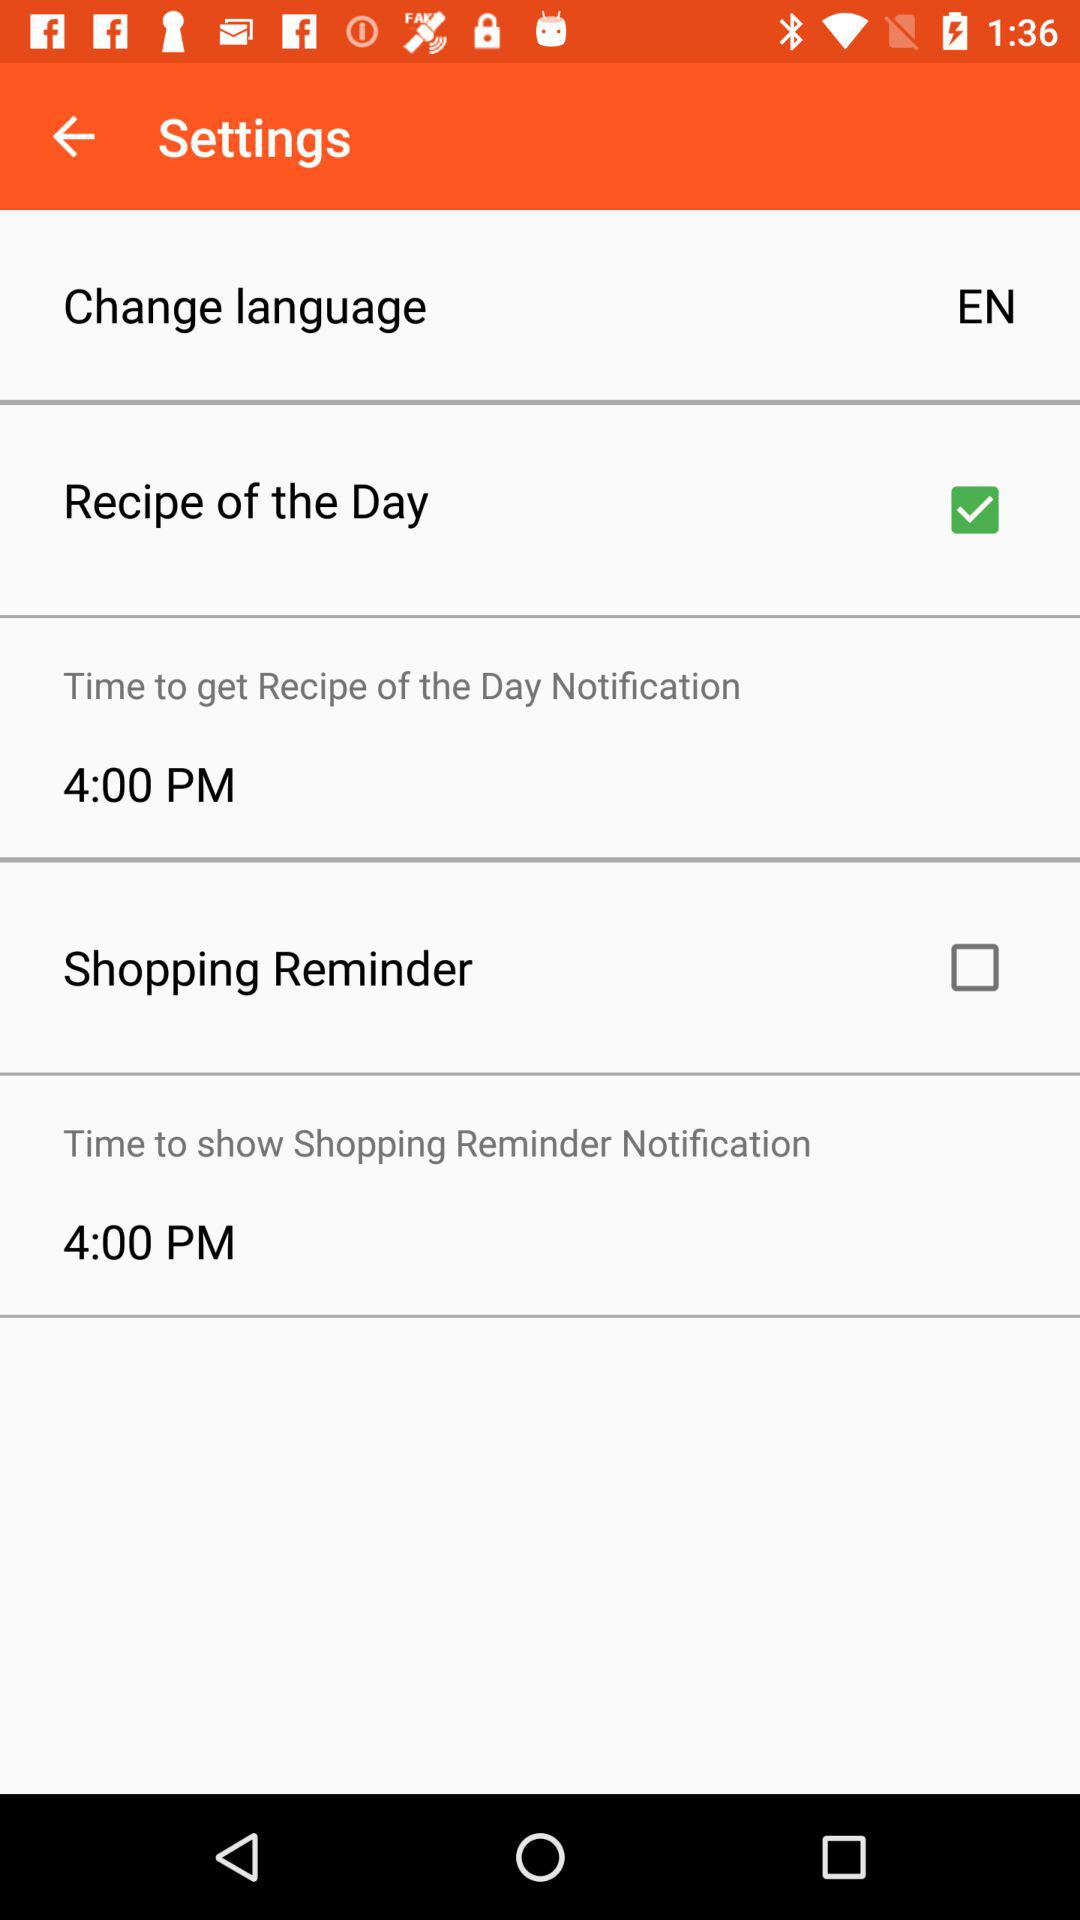What is the time mentioned for "Time to get Recipe of the Day Notification"? The time mentioned for "Time to get Recipe of the Day Notification" is 4:00 PM. 